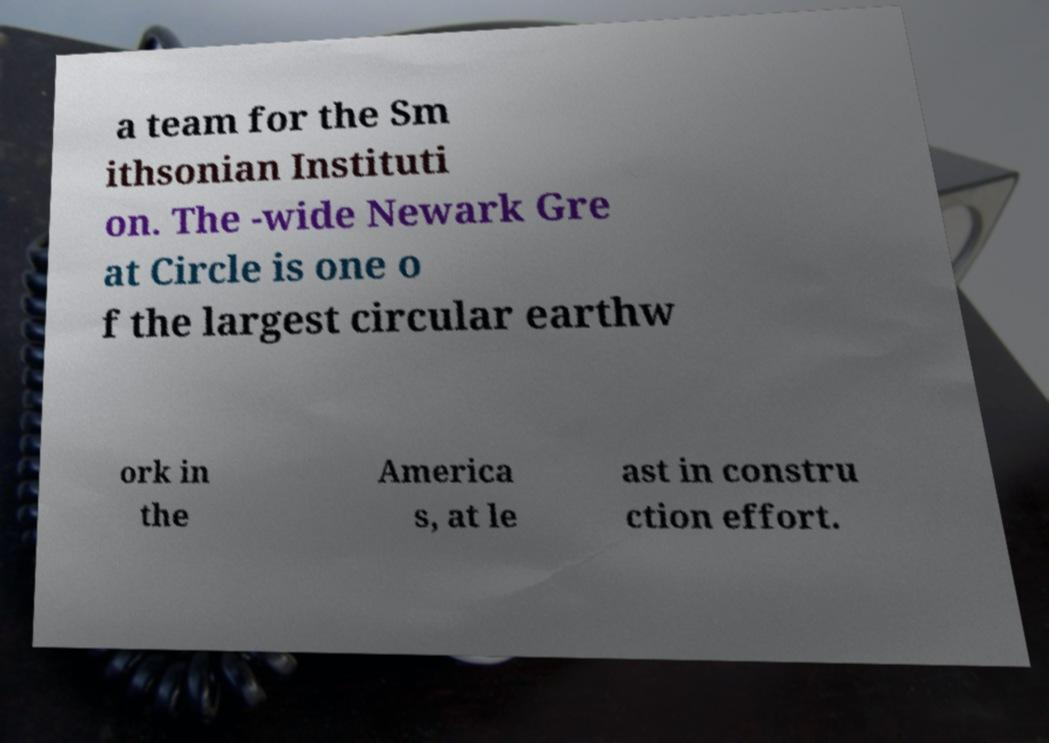Could you extract and type out the text from this image? a team for the Sm ithsonian Instituti on. The -wide Newark Gre at Circle is one o f the largest circular earthw ork in the America s, at le ast in constru ction effort. 